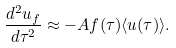<formula> <loc_0><loc_0><loc_500><loc_500>\frac { d ^ { 2 } u _ { f } } { d \tau ^ { 2 } } \approx - A f ( \tau ) \langle u ( \tau ) \rangle .</formula> 